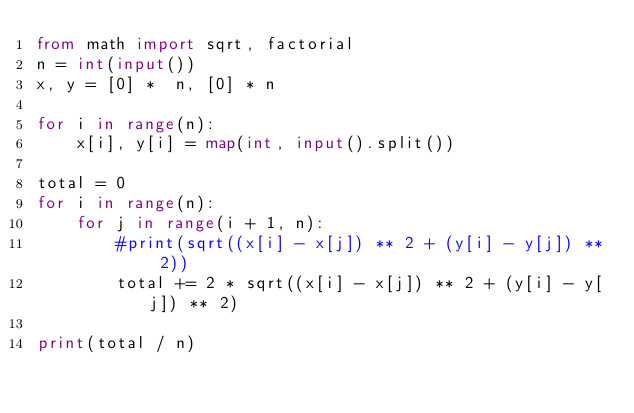Convert code to text. <code><loc_0><loc_0><loc_500><loc_500><_Python_>from math import sqrt, factorial
n = int(input())
x, y = [0] *  n, [0] * n

for i in range(n):
    x[i], y[i] = map(int, input().split())

total = 0
for i in range(n):
    for j in range(i + 1, n):
        #print(sqrt((x[i] - x[j]) ** 2 + (y[i] - y[j]) ** 2))
        total += 2 * sqrt((x[i] - x[j]) ** 2 + (y[i] - y[j]) ** 2)

print(total / n)</code> 